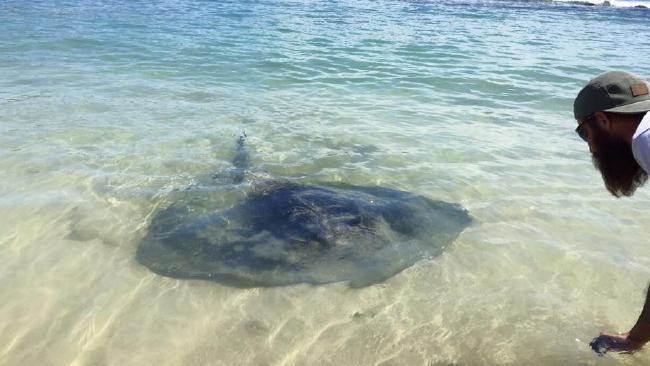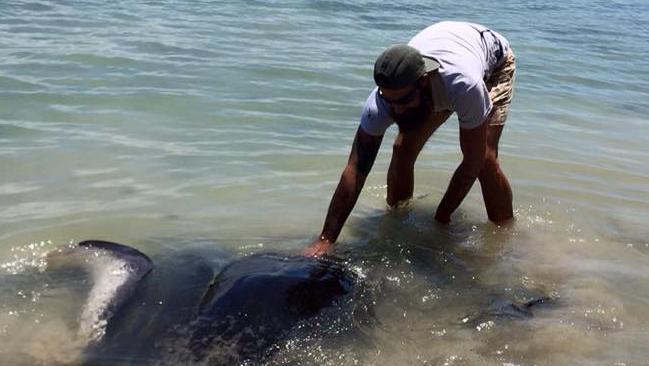The first image is the image on the left, the second image is the image on the right. Considering the images on both sides, is "In the right image a human is petting a stingray" valid? Answer yes or no. Yes. The first image is the image on the left, the second image is the image on the right. For the images displayed, is the sentence "There is a person reaching down and touching a stingray." factually correct? Answer yes or no. Yes. 